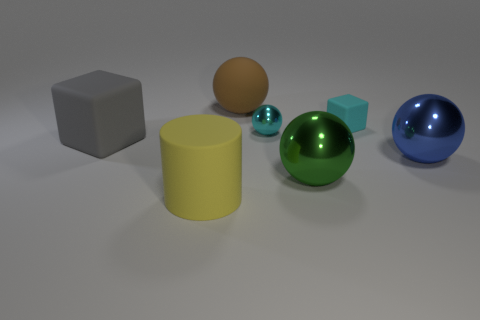Subtract all green metal spheres. How many spheres are left? 3 Add 2 tiny blue metal cylinders. How many objects exist? 9 Subtract all gray blocks. How many blocks are left? 1 Subtract all cylinders. How many objects are left? 6 Subtract 2 blocks. How many blocks are left? 0 Subtract all gray cylinders. How many cyan blocks are left? 1 Subtract all gray metallic cubes. Subtract all yellow cylinders. How many objects are left? 6 Add 1 cylinders. How many cylinders are left? 2 Add 5 big yellow rubber objects. How many big yellow rubber objects exist? 6 Subtract 0 purple balls. How many objects are left? 7 